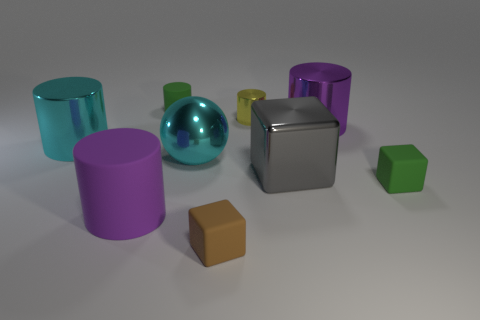What number of other things are made of the same material as the big gray thing?
Your response must be concise. 4. What is the shape of the green object that is the same size as the green matte cylinder?
Provide a short and direct response. Cube. Is there a small matte thing of the same color as the tiny metallic cylinder?
Your response must be concise. No. The tiny rubber thing in front of the green block has what shape?
Keep it short and to the point. Cube. What color is the sphere?
Give a very brief answer. Cyan. There is a large ball that is the same material as the large gray block; what color is it?
Offer a very short reply. Cyan. How many big balls have the same material as the gray thing?
Your answer should be compact. 1. There is a cyan ball; how many large purple metal things are behind it?
Give a very brief answer. 1. Do the big thing in front of the big gray thing and the cyan cylinder to the left of the brown rubber object have the same material?
Give a very brief answer. No. Is the number of yellow metallic things in front of the large cyan metallic sphere greater than the number of green matte blocks in front of the purple matte thing?
Your answer should be compact. No. 